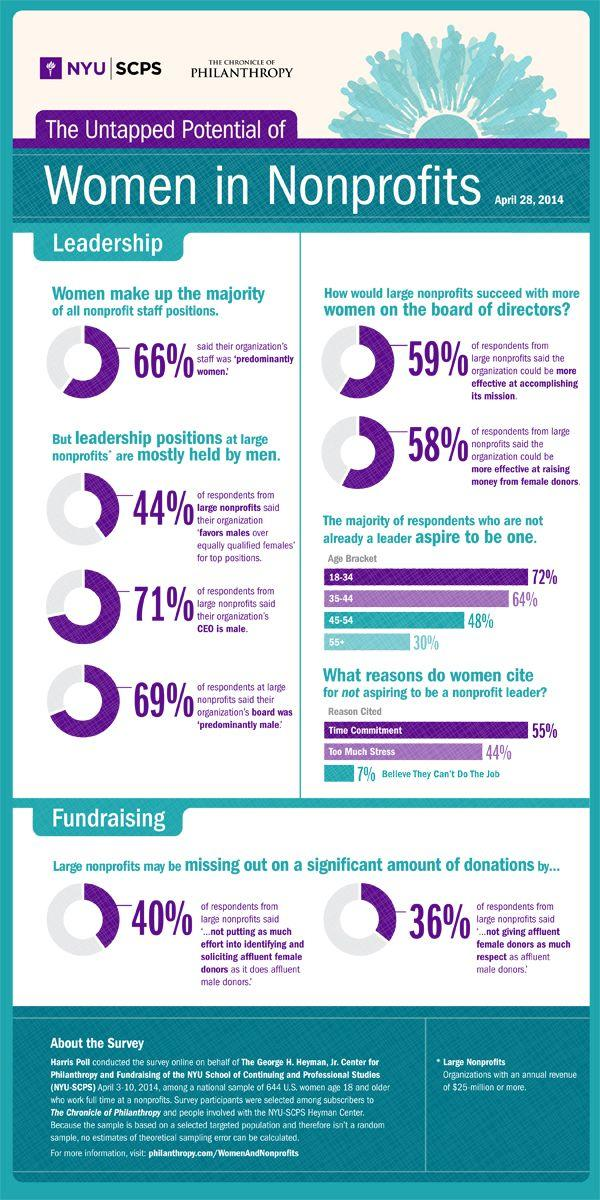Specify some key components in this picture. According to the data, 44% of top-level management positions are held by men. 